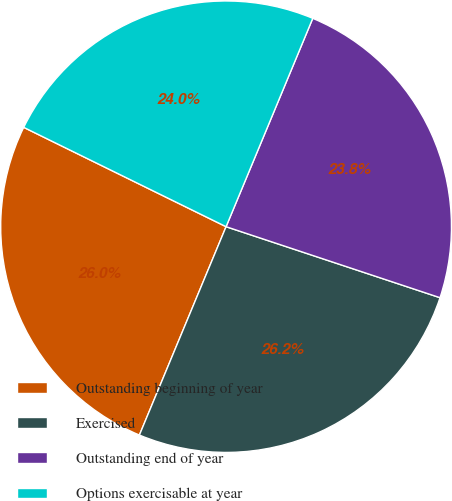Convert chart to OTSL. <chart><loc_0><loc_0><loc_500><loc_500><pie_chart><fcel>Outstanding beginning of year<fcel>Exercised<fcel>Outstanding end of year<fcel>Options exercisable at year<nl><fcel>25.97%<fcel>26.19%<fcel>23.81%<fcel>24.03%<nl></chart> 